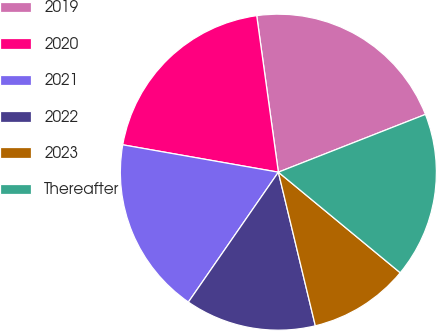Convert chart to OTSL. <chart><loc_0><loc_0><loc_500><loc_500><pie_chart><fcel>2019<fcel>2020<fcel>2021<fcel>2022<fcel>2023<fcel>Thereafter<nl><fcel>21.23%<fcel>20.04%<fcel>18.13%<fcel>13.4%<fcel>10.26%<fcel>16.94%<nl></chart> 